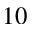<formula> <loc_0><loc_0><loc_500><loc_500>1 0</formula> 